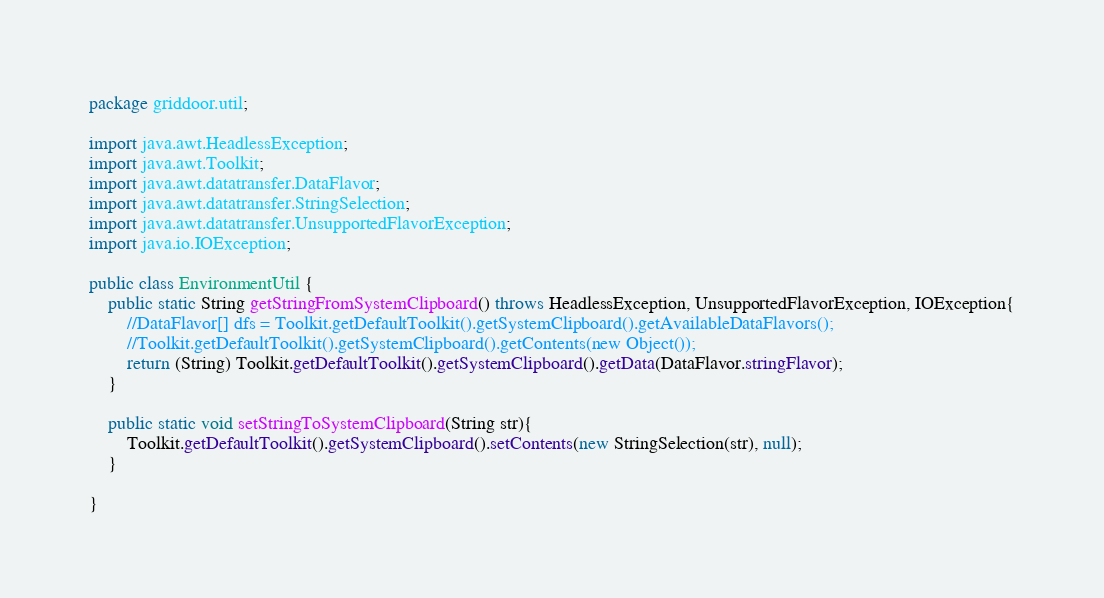<code> <loc_0><loc_0><loc_500><loc_500><_Java_>package griddoor.util;

import java.awt.HeadlessException;
import java.awt.Toolkit;
import java.awt.datatransfer.DataFlavor;
import java.awt.datatransfer.StringSelection;
import java.awt.datatransfer.UnsupportedFlavorException;
import java.io.IOException;

public class EnvironmentUtil {
	public static String getStringFromSystemClipboard() throws HeadlessException, UnsupportedFlavorException, IOException{
		//DataFlavor[] dfs = Toolkit.getDefaultToolkit().getSystemClipboard().getAvailableDataFlavors();
		//Toolkit.getDefaultToolkit().getSystemClipboard().getContents(new Object());
		return (String) Toolkit.getDefaultToolkit().getSystemClipboard().getData(DataFlavor.stringFlavor);
	}
	
	public static void setStringToSystemClipboard(String str){
		Toolkit.getDefaultToolkit().getSystemClipboard().setContents(new StringSelection(str), null);
	}

}
</code> 